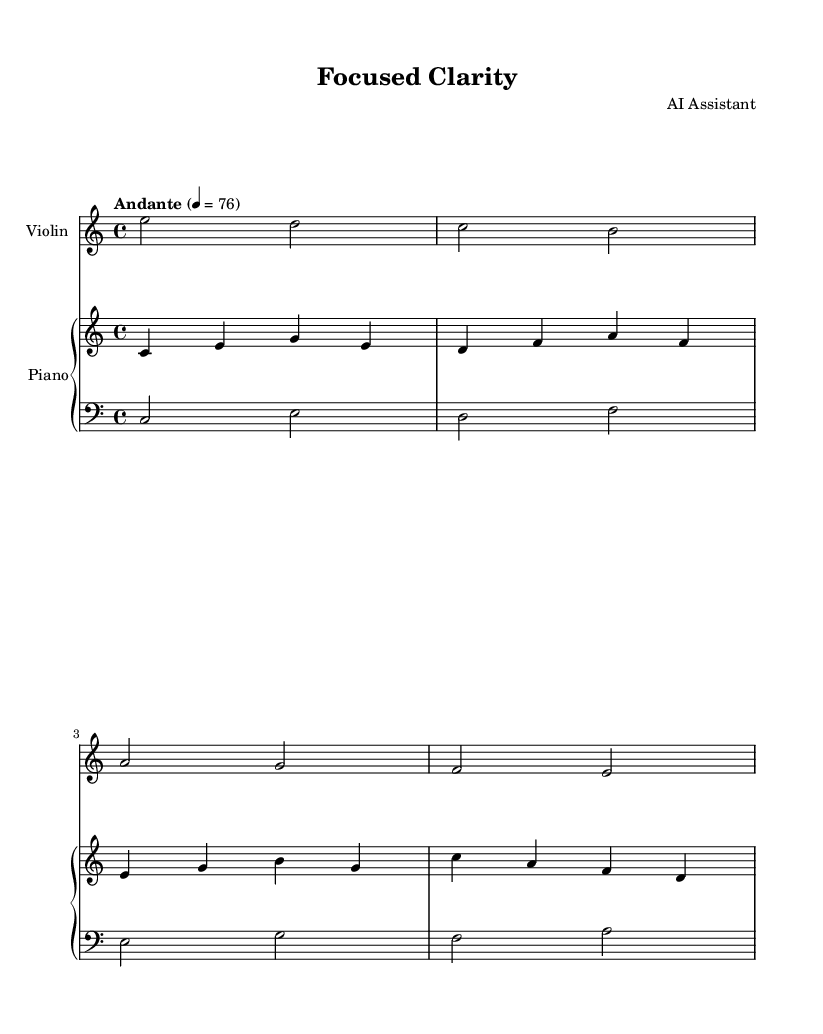What is the key signature of this music? The key signature is indicated at the beginning of the staff and shows no sharps or flats, which corresponds to C major.
Answer: C major What is the time signature of this composition? The time signature is displayed at the beginning of the piece, showing that there are four beats per measure, denoted as 4/4.
Answer: 4/4 What is the tempo indication for this piece? The tempo marking is found in the score, indicating a speed of Andante, which is commonly set at 76 beats per minute.
Answer: Andante How many measures are in the piano right hand part? By counting the individual measures provided in the piano right hand section, there are four measures visible.
Answer: 4 What is the range of the violin in this piece? The notes played by the violin, starting from E down to E, indicate a range spanning an octave from E2 to E3, showing its overall range.
Answer: Octave Is there a pattern in the left hand piano part? Analyzing the left hand part, we can observe a recurring pattern of moving down the scale, confirming a simple harmonic progression.
Answer: Yes How does the violin contribute to the overall mood of the symphony? The violin's melodic descent offers a calm and reflective quality, reinforcing the minimalist aesthetic and promoting concentration.
Answer: Calm 